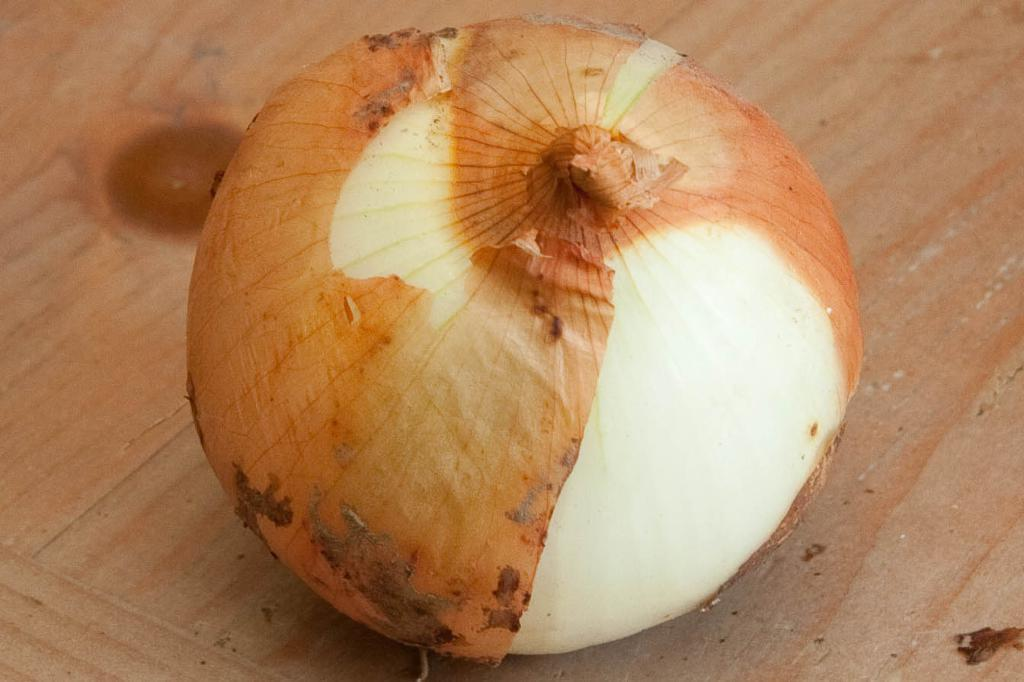What piece of furniture is present in the image? There is a table in the image. What is placed on the table? There is an onion on the table. What type of wax can be seen melting on the table in the image? There is no wax present in the image; it only features a table and an onion. 